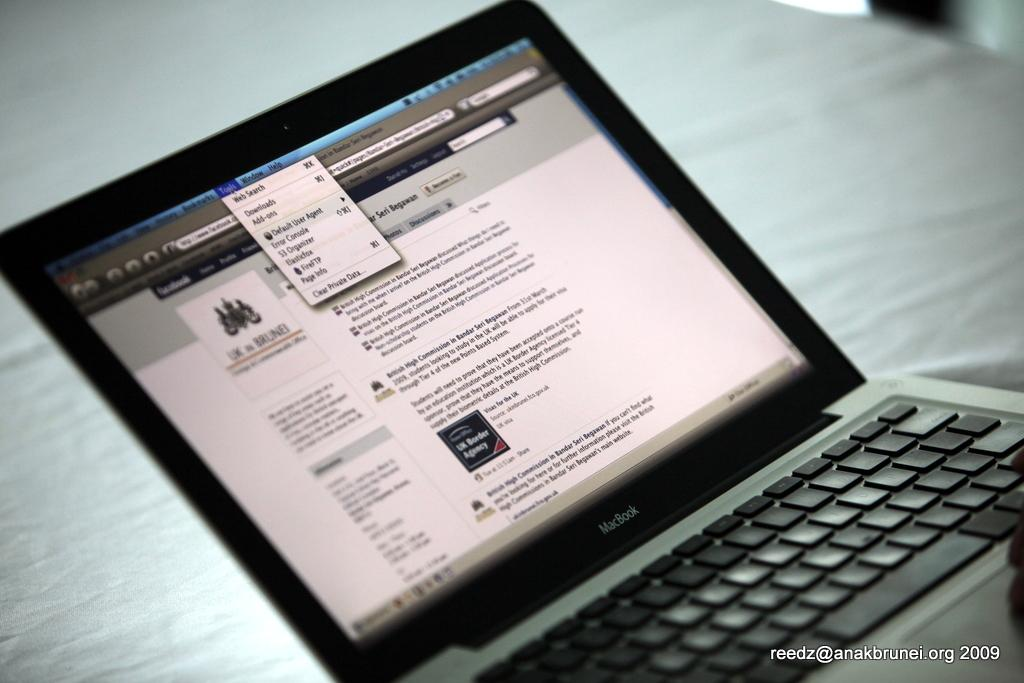What electronic device is present in the image? There is a laptop in the image. What are the main components of the laptop? The laptop has a screen and a keyboard. What can be seen on the screen of the laptop? The provided facts do not mention the content on the screen, so we cannot answer that question definitively. What is written at the bottom of the image? There is text visible at the bottom of the image. What type of toy is being used in an argument in the image? There is no toy or argument present in the image; it features a laptop with a screen and keyboard, and text at the bottom. 